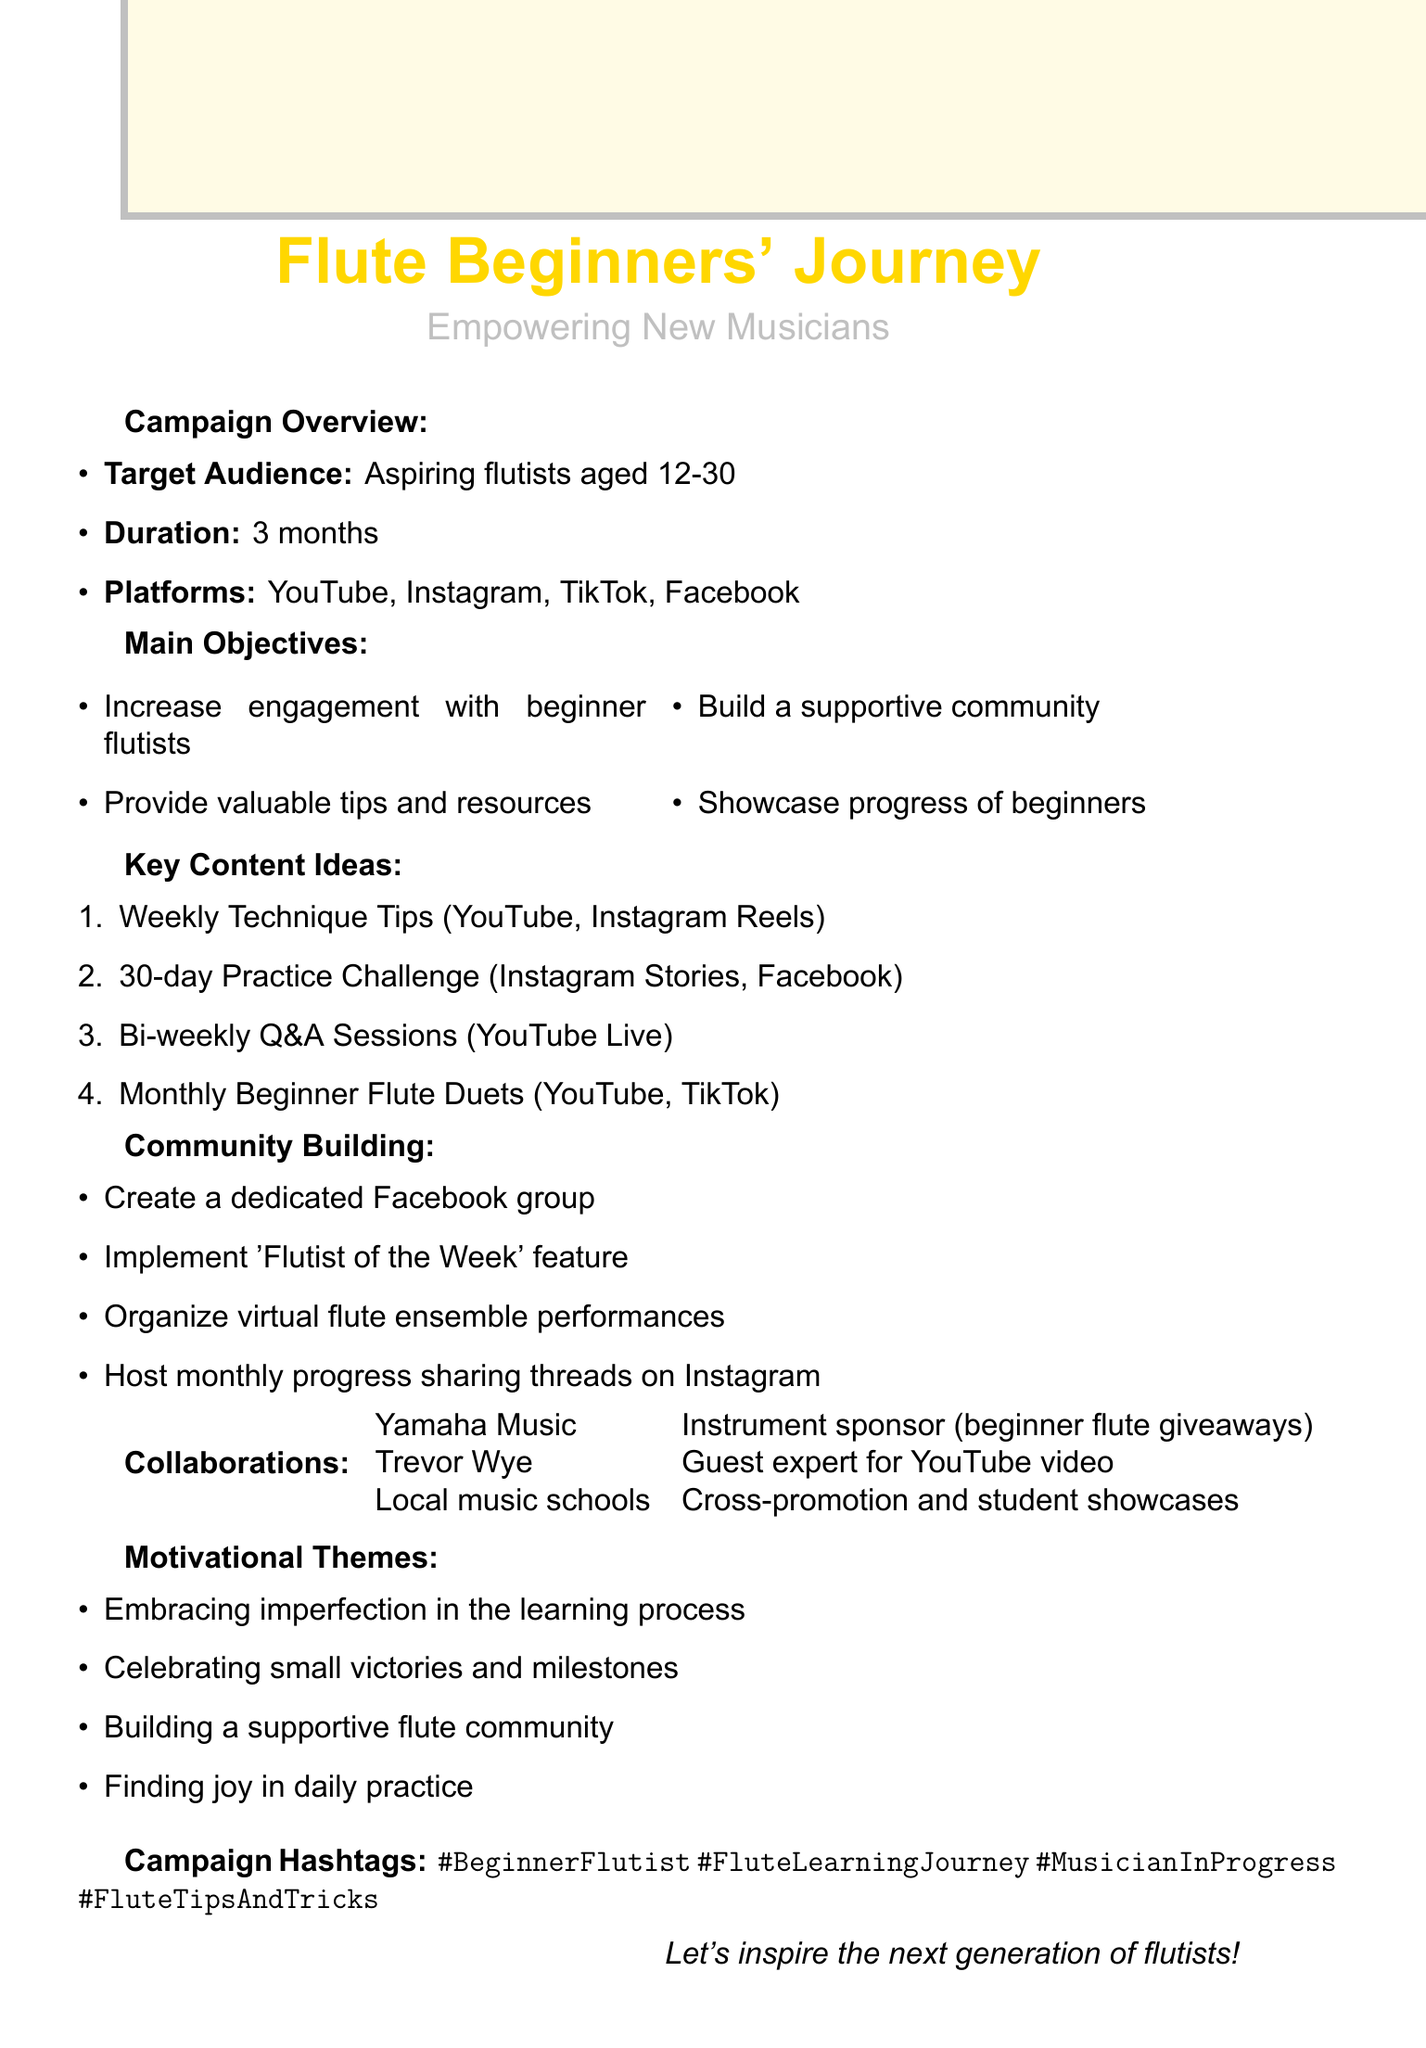What is the campaign title? The campaign title is the main focus of the document, aimed at beginner flutists.
Answer: Flute Beginners' Journey: Empowering New Musicians What is the duration of the campaign? The duration indicates how long the campaign will run, which is specified in the document.
Answer: 3 months Which platforms will be primarily used for the campaign? The platforms section lists the social media outlets chosen for the campaign's activities.
Answer: YouTube, Instagram, TikTok, Facebook How often will the Q&A sessions be held? The frequency of Q&A sessions provides insight into the engagement strategy with beginner flutists.
Answer: Bi-weekly What is one of the main objectives of the campaign? The main objective section specifies the goals of the campaign, one of which is noteworthy.
Answer: Build a supportive community What are the motivational themes mentioned in the document? This question requires an understanding of the themes presented for encouragement throughout the campaign.
Answer: Embracing imperfection in the learning process Who is contributing flutes for the giveaways? This question pertains to the collaboration section, highlighting a specific partnership for the campaign.
Answer: Yamaha Music How many content ideas are listed in the document? The count of content ideas reflects the variety of engagement strategies planned for the campaign.
Answer: 4 What type of resource will be created as a downloadable PDF? This requires synthesizing information about the resources mentioned in the document.
Answer: Beginner's Guide to Flute Care 